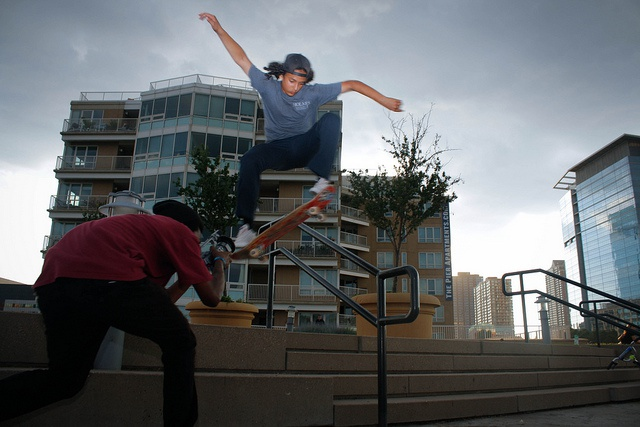Describe the objects in this image and their specific colors. I can see people in gray, black, maroon, and purple tones, people in gray, black, maroon, and blue tones, potted plant in gray, black, lightgray, and maroon tones, potted plant in gray, black, and maroon tones, and skateboard in gray, maroon, and black tones in this image. 